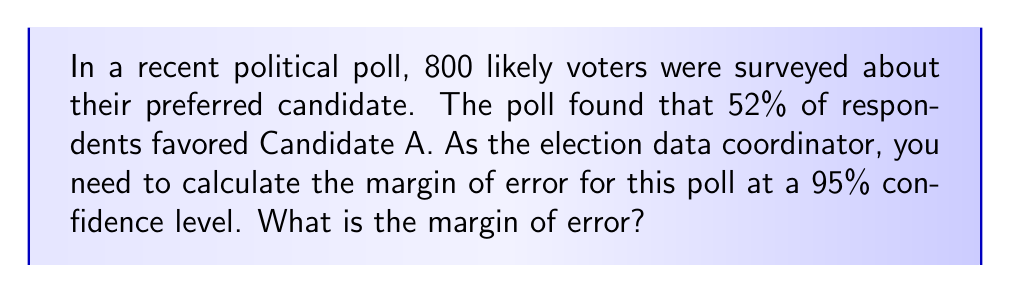Give your solution to this math problem. To calculate the margin of error for this poll, we'll follow these steps:

1. Identify the components:
   - Sample size (n) = 800
   - Sample proportion (p) = 0.52 (52% expressed as a decimal)
   - Confidence level = 95% (z-score = 1.96)

2. Use the formula for margin of error (MOE):
   $$ MOE = z \sqrt{\frac{p(1-p)}{n}} $$

3. Substitute the values:
   $$ MOE = 1.96 \sqrt{\frac{0.52(1-0.52)}{800}} $$

4. Simplify:
   $$ MOE = 1.96 \sqrt{\frac{0.52(0.48)}{800}} $$
   $$ MOE = 1.96 \sqrt{\frac{0.2496}{800}} $$
   $$ MOE = 1.96 \sqrt{0.000312} $$
   $$ MOE = 1.96 * 0.01766 $$
   $$ MOE = 0.03461 $$

5. Convert to percentage:
   $$ MOE = 0.03461 * 100 = 3.461\% $$

6. Round to three decimal places:
   $$ MOE ≈ 3.461\% $$
Answer: 3.461% 